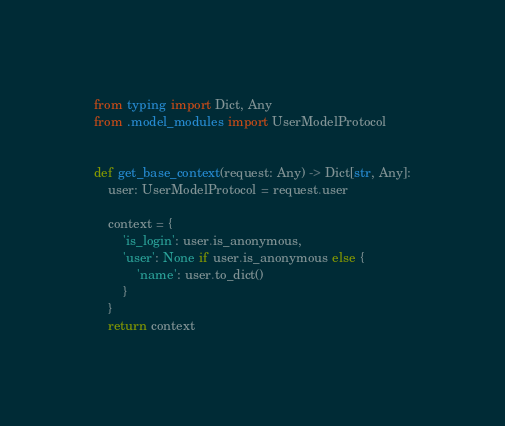Convert code to text. <code><loc_0><loc_0><loc_500><loc_500><_Python_>from typing import Dict, Any
from .model_modules import UserModelProtocol


def get_base_context(request: Any) -> Dict[str, Any]:
    user: UserModelProtocol = request.user

    context = {
        'is_login': user.is_anonymous,
        'user': None if user.is_anonymous else {
            'name': user.to_dict()
        }
    }
    return context
</code> 